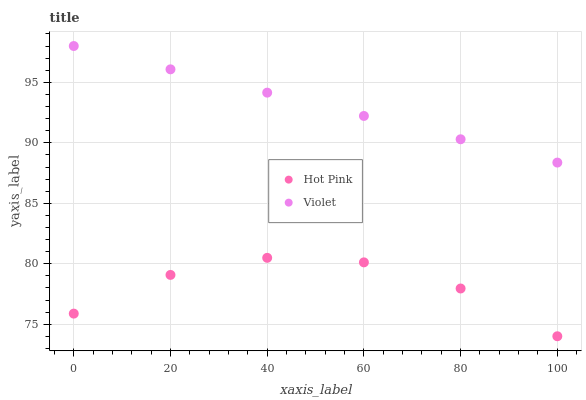Does Hot Pink have the minimum area under the curve?
Answer yes or no. Yes. Does Violet have the maximum area under the curve?
Answer yes or no. Yes. Does Violet have the minimum area under the curve?
Answer yes or no. No. Is Violet the smoothest?
Answer yes or no. Yes. Is Hot Pink the roughest?
Answer yes or no. Yes. Is Violet the roughest?
Answer yes or no. No. Does Hot Pink have the lowest value?
Answer yes or no. Yes. Does Violet have the lowest value?
Answer yes or no. No. Does Violet have the highest value?
Answer yes or no. Yes. Is Hot Pink less than Violet?
Answer yes or no. Yes. Is Violet greater than Hot Pink?
Answer yes or no. Yes. Does Hot Pink intersect Violet?
Answer yes or no. No. 